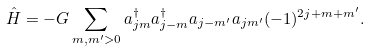Convert formula to latex. <formula><loc_0><loc_0><loc_500><loc_500>\hat { H } = - G \sum _ { m , m ^ { \prime } > 0 } a ^ { \dag } _ { j m } a ^ { \dag } _ { j - m } a _ { j - m ^ { \prime } } a _ { j m ^ { \prime } } ( - 1 ) ^ { 2 j + m + m ^ { \prime } } .</formula> 